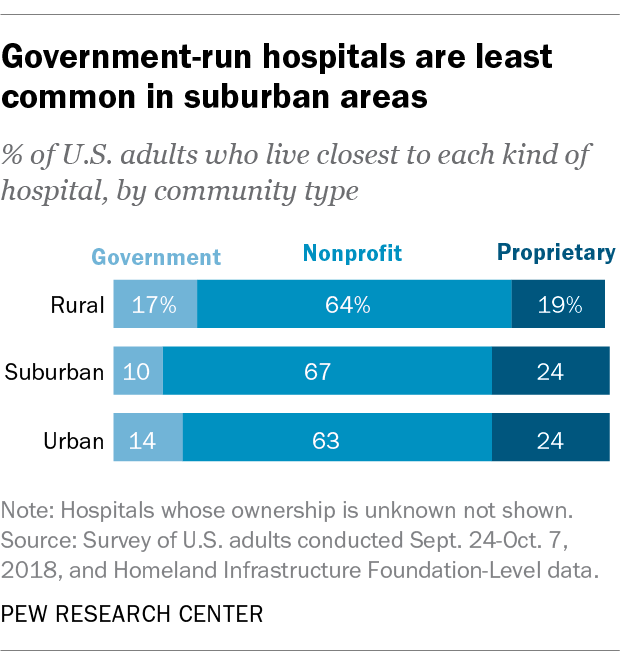Indicate a few pertinent items in this graphic. The proprietary bar color is dark blue. The value of proprietary is greater in urban areas than in rural areas. 